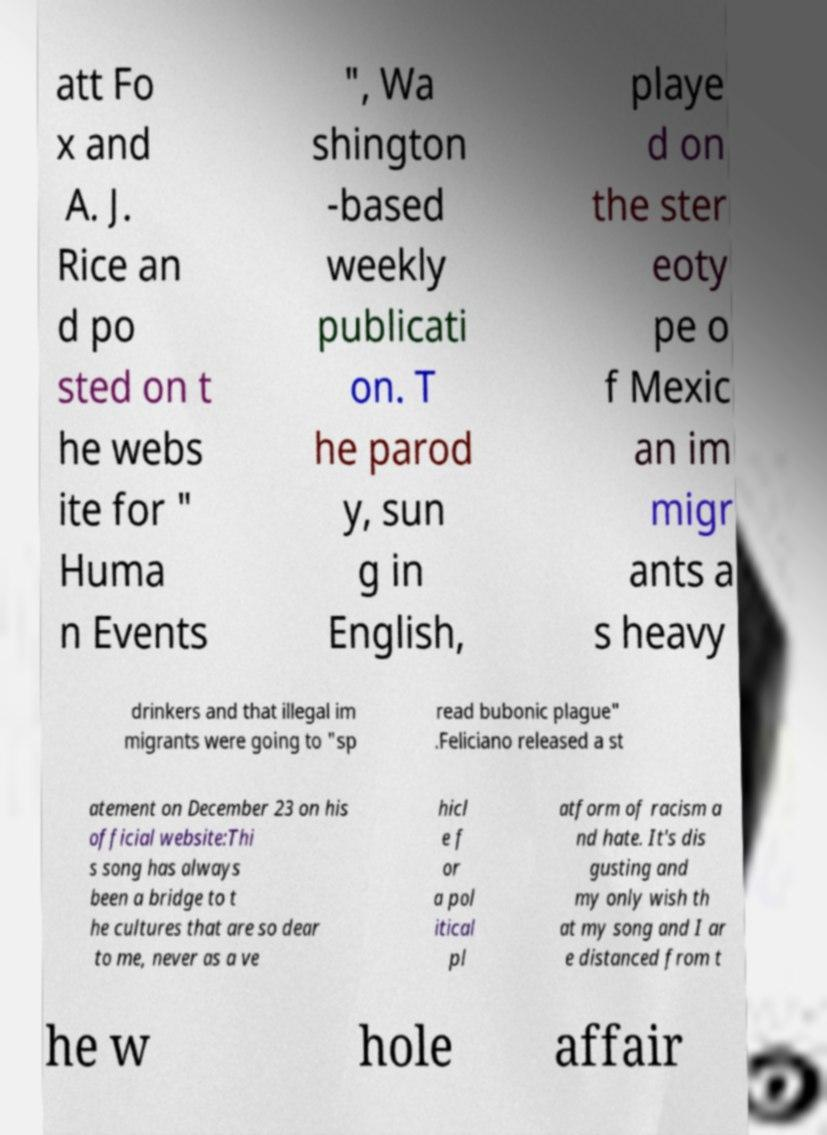Please read and relay the text visible in this image. What does it say? att Fo x and A. J. Rice an d po sted on t he webs ite for " Huma n Events ", Wa shington -based weekly publicati on. T he parod y, sun g in English, playe d on the ster eoty pe o f Mexic an im migr ants a s heavy drinkers and that illegal im migrants were going to "sp read bubonic plague" .Feliciano released a st atement on December 23 on his official website:Thi s song has always been a bridge to t he cultures that are so dear to me, never as a ve hicl e f or a pol itical pl atform of racism a nd hate. It's dis gusting and my only wish th at my song and I ar e distanced from t he w hole affair 